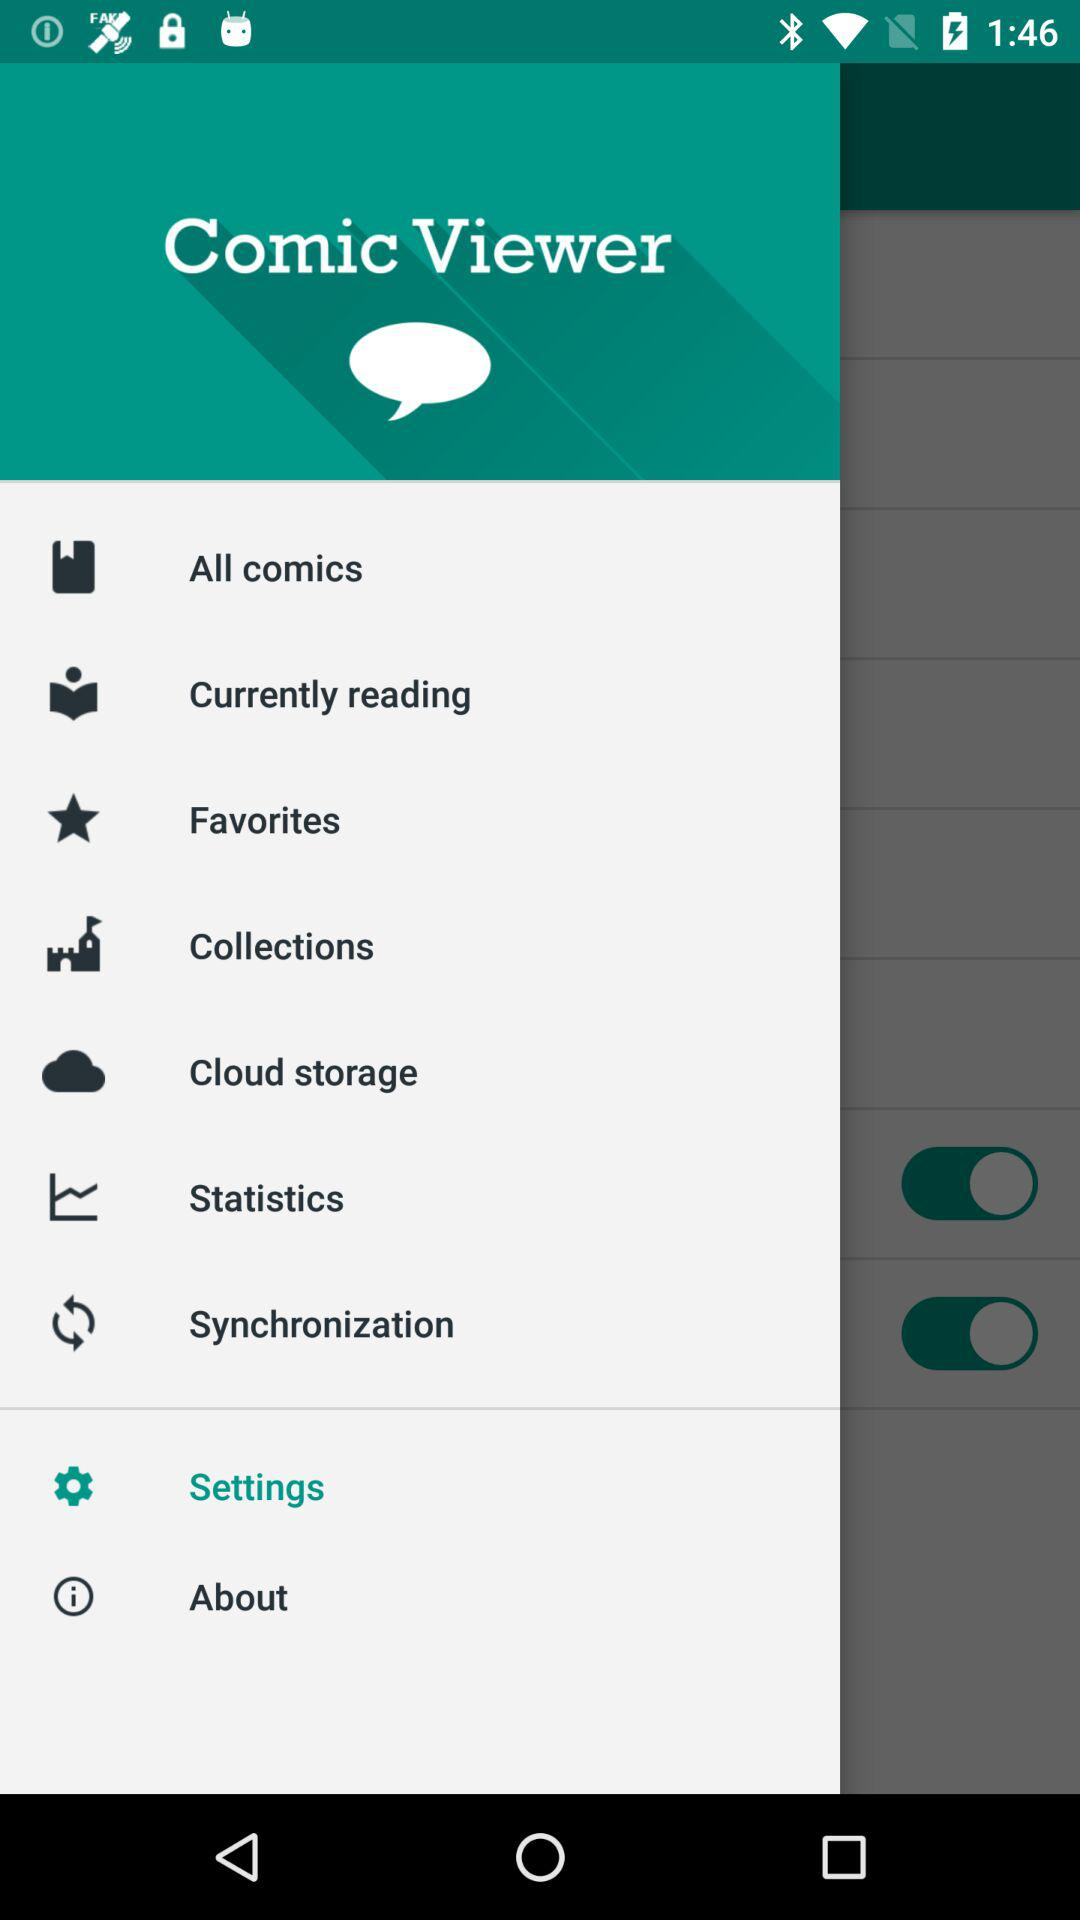How many switches are there in the menu?
Answer the question using a single word or phrase. 2 